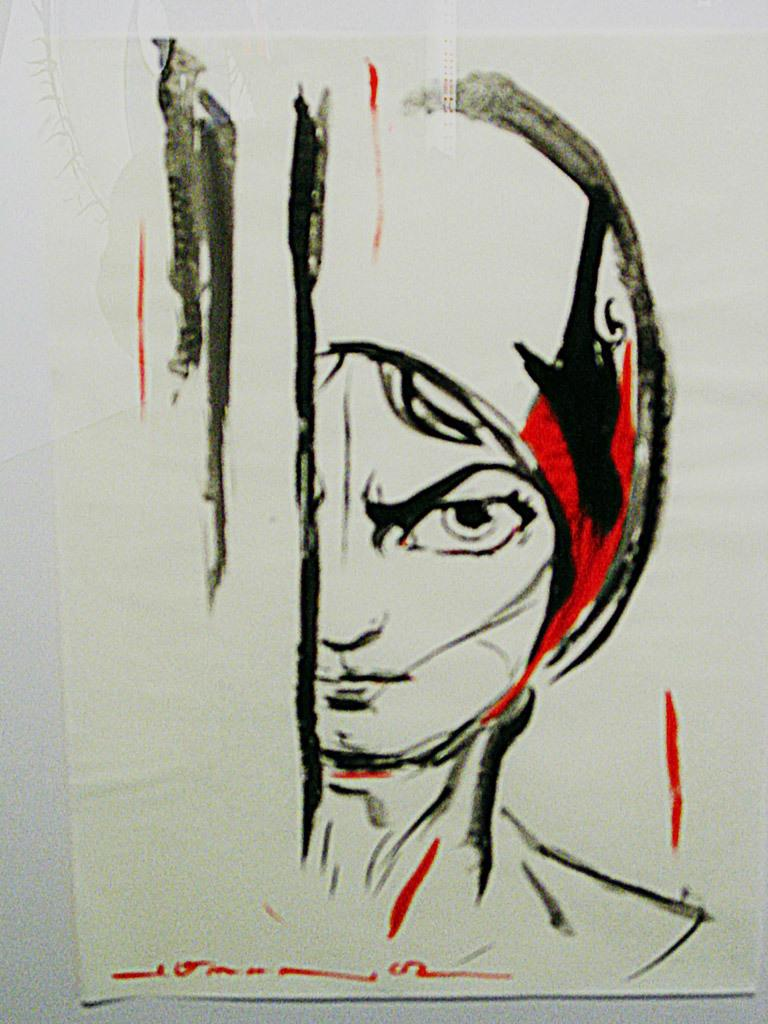What is present in the image? There is a paper in the image. What is depicted on the paper? The paper contains an art of a human. What is the rate of the basketball bouncing in the image? There is no basketball present in the image, so it is not possible to determine the rate of its bouncing. 